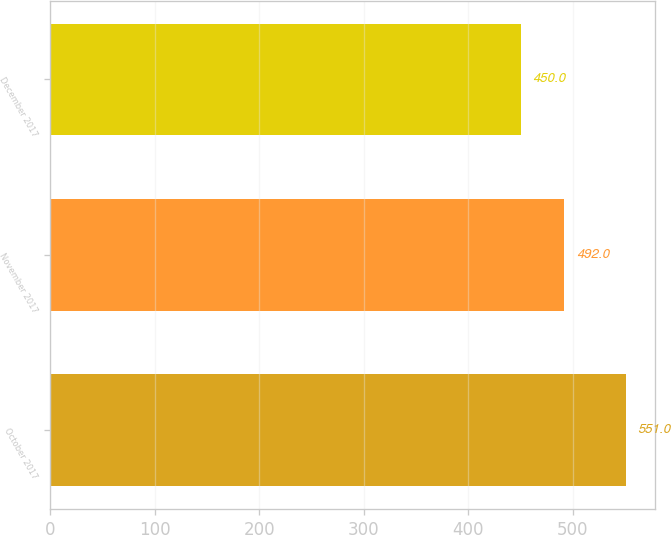Convert chart. <chart><loc_0><loc_0><loc_500><loc_500><bar_chart><fcel>October 2017<fcel>November 2017<fcel>December 2017<nl><fcel>551<fcel>492<fcel>450<nl></chart> 